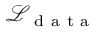<formula> <loc_0><loc_0><loc_500><loc_500>\mathcal { L } _ { d a t a }</formula> 